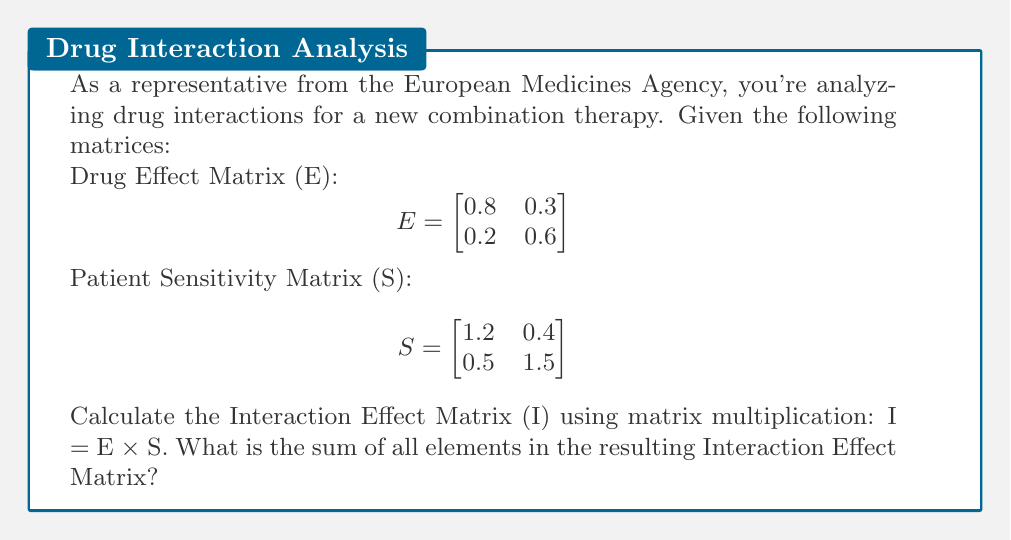Could you help me with this problem? To solve this problem, we need to follow these steps:

1. Perform matrix multiplication of E and S to get I.
2. Sum all elements in the resulting matrix I.

Step 1: Matrix multiplication I = E × S

$$I = \begin{bmatrix}
0.8 & 0.3 \\
0.2 & 0.6
\end{bmatrix} \times \begin{bmatrix}
1.2 & 0.4 \\
0.5 & 1.5
\end{bmatrix}$$

Calculating each element of I:

$I_{11} = (0.8 \times 1.2) + (0.3 \times 0.5) = 0.96 + 0.15 = 1.11$
$I_{12} = (0.8 \times 0.4) + (0.3 \times 1.5) = 0.32 + 0.45 = 0.77$
$I_{21} = (0.2 \times 1.2) + (0.6 \times 0.5) = 0.24 + 0.30 = 0.54$
$I_{22} = (0.2 \times 0.4) + (0.6 \times 1.5) = 0.08 + 0.90 = 0.98$

Therefore, the Interaction Effect Matrix is:

$$I = \begin{bmatrix}
1.11 & 0.77 \\
0.54 & 0.98
\end{bmatrix}$$

Step 2: Sum all elements in matrix I

Sum = 1.11 + 0.77 + 0.54 + 0.98 = 3.40
Answer: 3.40 